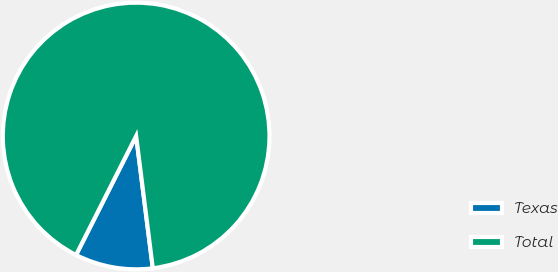Convert chart. <chart><loc_0><loc_0><loc_500><loc_500><pie_chart><fcel>Texas<fcel>Total<nl><fcel>9.44%<fcel>90.56%<nl></chart> 